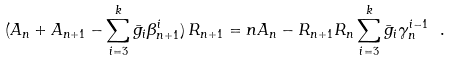Convert formula to latex. <formula><loc_0><loc_0><loc_500><loc_500>( A _ { n } + A _ { n + 1 } - \sum _ { i = 3 } ^ { k } \bar { g } _ { i } \beta ^ { i } _ { n + 1 } ) \, R _ { n + 1 } = n A _ { n } - R _ { n + 1 } R _ { n } \sum _ { i = 3 } ^ { k } \bar { g } _ { i } \gamma _ { n } ^ { i - 1 } \ .</formula> 